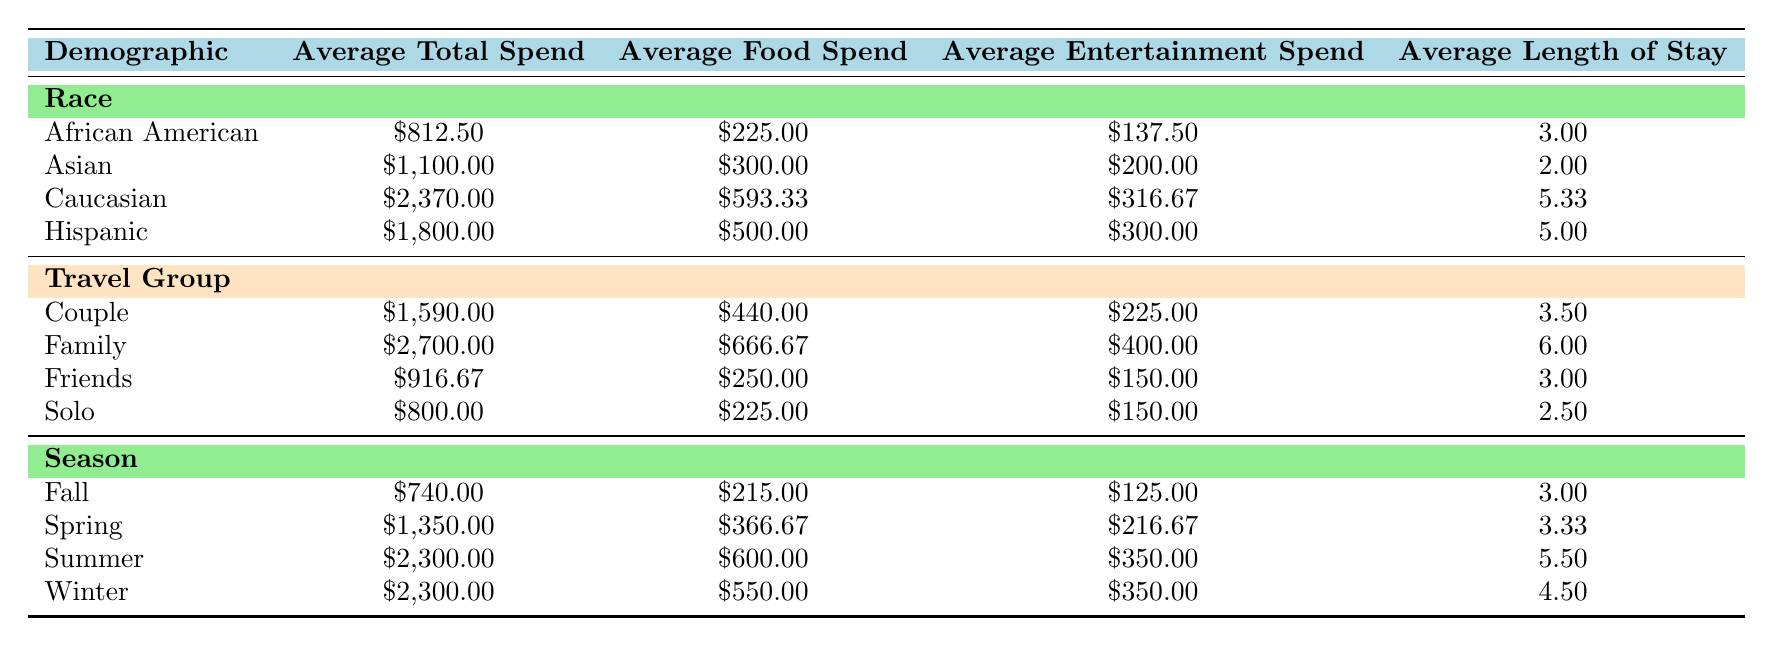What is the average total spend for African American visitors? The table states that the average total spend for African American visitors is $812.50.
Answer: $812.50 What is the average food spend for visitors traveling as a couple? According to the table, visitors traveling as a couple spend an average of $440.00 on food.
Answer: $440.00 How does the average total spend of Hispanic visitors compare to that of Asian visitors? The average total spend for Hispanic visitors is $1,800.00 while for Asian visitors it is $1,100.00. Comparing these two values shows Hispanic visitors spend $700.00 more than Asian visitors.
Answer: Hispanic visitors spend $700.00 more Is the average length of stay longer in winter or summer? The average length of stay in winter is 4.5 days and in summer is 5.5 days. Since 5.5 is greater than 4.5, summer has a longer average length of stay.
Answer: Summer What is the total average spending on entertainment for family travelers compared to solo travelers? Family travelers have an average entertainment spend of $400.00, while solo travelers have an average of $150.00. The difference in entertainment spending is $250.00, showing family travelers spend significantly more on entertainment.
Answer: $250.00 more for family travelers What is the average total spend for visitors during the spring season? The table indicates that the average total spend for visitors during the spring season is $1,350.00.
Answer: $1,350.00 Which demographic has the highest average shopping spend? Looking at the table, Caucasian visitors have the highest average shopping spend of $316.67, compared to other demographics listed.
Answer: Caucasian visitors Does the average food spend exceed $600.00 for any group? Checking the table, the only group with an average food spend that exceeds $600.00 is visitors classified as family, with $666.67. Thus, it is true that one group exceeds $600.00.
Answer: Yes During which season do visitors spend the least in total? The table shows that fall visitors have the lowest average total spending at $740.00 compared to other seasons.
Answer: Fall 